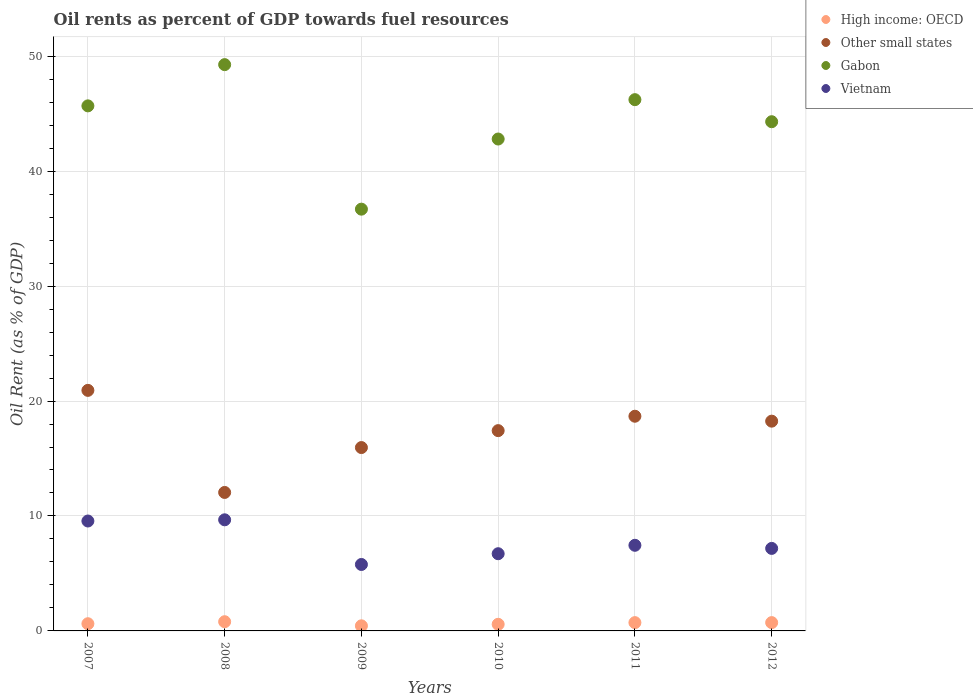What is the oil rent in Vietnam in 2008?
Offer a very short reply. 9.67. Across all years, what is the maximum oil rent in Other small states?
Keep it short and to the point. 20.93. Across all years, what is the minimum oil rent in High income: OECD?
Your answer should be very brief. 0.44. In which year was the oil rent in Vietnam maximum?
Provide a succinct answer. 2008. What is the total oil rent in Vietnam in the graph?
Your answer should be compact. 46.35. What is the difference between the oil rent in Vietnam in 2007 and that in 2010?
Provide a short and direct response. 2.85. What is the difference between the oil rent in Gabon in 2012 and the oil rent in Vietnam in 2008?
Offer a very short reply. 34.63. What is the average oil rent in High income: OECD per year?
Offer a terse response. 0.65. In the year 2011, what is the difference between the oil rent in Vietnam and oil rent in Gabon?
Your response must be concise. -38.77. What is the ratio of the oil rent in High income: OECD in 2008 to that in 2012?
Ensure brevity in your answer.  1.11. What is the difference between the highest and the second highest oil rent in Other small states?
Provide a short and direct response. 2.25. What is the difference between the highest and the lowest oil rent in High income: OECD?
Keep it short and to the point. 0.36. Is the sum of the oil rent in Other small states in 2010 and 2011 greater than the maximum oil rent in High income: OECD across all years?
Make the answer very short. Yes. Is it the case that in every year, the sum of the oil rent in Gabon and oil rent in Vietnam  is greater than the sum of oil rent in Other small states and oil rent in High income: OECD?
Keep it short and to the point. No. Is the oil rent in Gabon strictly greater than the oil rent in High income: OECD over the years?
Provide a succinct answer. Yes. Is the oil rent in High income: OECD strictly less than the oil rent in Gabon over the years?
Make the answer very short. Yes. How many dotlines are there?
Ensure brevity in your answer.  4. What is the difference between two consecutive major ticks on the Y-axis?
Provide a short and direct response. 10. Are the values on the major ticks of Y-axis written in scientific E-notation?
Your response must be concise. No. Does the graph contain any zero values?
Ensure brevity in your answer.  No. Does the graph contain grids?
Your answer should be very brief. Yes. Where does the legend appear in the graph?
Provide a short and direct response. Top right. How many legend labels are there?
Offer a very short reply. 4. What is the title of the graph?
Offer a terse response. Oil rents as percent of GDP towards fuel resources. Does "China" appear as one of the legend labels in the graph?
Your answer should be compact. No. What is the label or title of the Y-axis?
Make the answer very short. Oil Rent (as % of GDP). What is the Oil Rent (as % of GDP) in High income: OECD in 2007?
Your answer should be compact. 0.63. What is the Oil Rent (as % of GDP) of Other small states in 2007?
Give a very brief answer. 20.93. What is the Oil Rent (as % of GDP) of Gabon in 2007?
Your answer should be compact. 45.68. What is the Oil Rent (as % of GDP) in Vietnam in 2007?
Ensure brevity in your answer.  9.56. What is the Oil Rent (as % of GDP) of High income: OECD in 2008?
Your response must be concise. 0.8. What is the Oil Rent (as % of GDP) of Other small states in 2008?
Your response must be concise. 12.05. What is the Oil Rent (as % of GDP) of Gabon in 2008?
Ensure brevity in your answer.  49.26. What is the Oil Rent (as % of GDP) in Vietnam in 2008?
Make the answer very short. 9.67. What is the Oil Rent (as % of GDP) in High income: OECD in 2009?
Make the answer very short. 0.44. What is the Oil Rent (as % of GDP) of Other small states in 2009?
Offer a terse response. 15.95. What is the Oil Rent (as % of GDP) of Gabon in 2009?
Give a very brief answer. 36.69. What is the Oil Rent (as % of GDP) of Vietnam in 2009?
Your answer should be very brief. 5.78. What is the Oil Rent (as % of GDP) in High income: OECD in 2010?
Offer a very short reply. 0.58. What is the Oil Rent (as % of GDP) of Other small states in 2010?
Your answer should be compact. 17.42. What is the Oil Rent (as % of GDP) of Gabon in 2010?
Provide a succinct answer. 42.79. What is the Oil Rent (as % of GDP) in Vietnam in 2010?
Your answer should be compact. 6.72. What is the Oil Rent (as % of GDP) of High income: OECD in 2011?
Keep it short and to the point. 0.72. What is the Oil Rent (as % of GDP) in Other small states in 2011?
Give a very brief answer. 18.68. What is the Oil Rent (as % of GDP) of Gabon in 2011?
Provide a succinct answer. 46.22. What is the Oil Rent (as % of GDP) of Vietnam in 2011?
Provide a short and direct response. 7.45. What is the Oil Rent (as % of GDP) in High income: OECD in 2012?
Provide a short and direct response. 0.72. What is the Oil Rent (as % of GDP) in Other small states in 2012?
Provide a short and direct response. 18.25. What is the Oil Rent (as % of GDP) of Gabon in 2012?
Keep it short and to the point. 44.3. What is the Oil Rent (as % of GDP) in Vietnam in 2012?
Keep it short and to the point. 7.18. Across all years, what is the maximum Oil Rent (as % of GDP) of High income: OECD?
Your answer should be compact. 0.8. Across all years, what is the maximum Oil Rent (as % of GDP) in Other small states?
Make the answer very short. 20.93. Across all years, what is the maximum Oil Rent (as % of GDP) in Gabon?
Give a very brief answer. 49.26. Across all years, what is the maximum Oil Rent (as % of GDP) in Vietnam?
Your answer should be very brief. 9.67. Across all years, what is the minimum Oil Rent (as % of GDP) of High income: OECD?
Your response must be concise. 0.44. Across all years, what is the minimum Oil Rent (as % of GDP) of Other small states?
Provide a short and direct response. 12.05. Across all years, what is the minimum Oil Rent (as % of GDP) of Gabon?
Offer a terse response. 36.69. Across all years, what is the minimum Oil Rent (as % of GDP) of Vietnam?
Provide a succinct answer. 5.78. What is the total Oil Rent (as % of GDP) of High income: OECD in the graph?
Offer a terse response. 3.89. What is the total Oil Rent (as % of GDP) in Other small states in the graph?
Give a very brief answer. 103.27. What is the total Oil Rent (as % of GDP) in Gabon in the graph?
Your response must be concise. 264.94. What is the total Oil Rent (as % of GDP) of Vietnam in the graph?
Make the answer very short. 46.35. What is the difference between the Oil Rent (as % of GDP) of High income: OECD in 2007 and that in 2008?
Offer a terse response. -0.17. What is the difference between the Oil Rent (as % of GDP) in Other small states in 2007 and that in 2008?
Offer a very short reply. 8.88. What is the difference between the Oil Rent (as % of GDP) in Gabon in 2007 and that in 2008?
Ensure brevity in your answer.  -3.59. What is the difference between the Oil Rent (as % of GDP) of Vietnam in 2007 and that in 2008?
Offer a very short reply. -0.1. What is the difference between the Oil Rent (as % of GDP) of High income: OECD in 2007 and that in 2009?
Ensure brevity in your answer.  0.18. What is the difference between the Oil Rent (as % of GDP) in Other small states in 2007 and that in 2009?
Make the answer very short. 4.98. What is the difference between the Oil Rent (as % of GDP) of Gabon in 2007 and that in 2009?
Offer a terse response. 8.99. What is the difference between the Oil Rent (as % of GDP) in Vietnam in 2007 and that in 2009?
Ensure brevity in your answer.  3.78. What is the difference between the Oil Rent (as % of GDP) in High income: OECD in 2007 and that in 2010?
Ensure brevity in your answer.  0.05. What is the difference between the Oil Rent (as % of GDP) of Other small states in 2007 and that in 2010?
Your answer should be very brief. 3.5. What is the difference between the Oil Rent (as % of GDP) in Gabon in 2007 and that in 2010?
Keep it short and to the point. 2.88. What is the difference between the Oil Rent (as % of GDP) in Vietnam in 2007 and that in 2010?
Make the answer very short. 2.85. What is the difference between the Oil Rent (as % of GDP) of High income: OECD in 2007 and that in 2011?
Your response must be concise. -0.1. What is the difference between the Oil Rent (as % of GDP) in Other small states in 2007 and that in 2011?
Ensure brevity in your answer.  2.25. What is the difference between the Oil Rent (as % of GDP) in Gabon in 2007 and that in 2011?
Offer a very short reply. -0.54. What is the difference between the Oil Rent (as % of GDP) of Vietnam in 2007 and that in 2011?
Your response must be concise. 2.11. What is the difference between the Oil Rent (as % of GDP) in High income: OECD in 2007 and that in 2012?
Your answer should be very brief. -0.1. What is the difference between the Oil Rent (as % of GDP) of Other small states in 2007 and that in 2012?
Keep it short and to the point. 2.68. What is the difference between the Oil Rent (as % of GDP) in Gabon in 2007 and that in 2012?
Provide a succinct answer. 1.38. What is the difference between the Oil Rent (as % of GDP) of Vietnam in 2007 and that in 2012?
Keep it short and to the point. 2.38. What is the difference between the Oil Rent (as % of GDP) of High income: OECD in 2008 and that in 2009?
Provide a short and direct response. 0.36. What is the difference between the Oil Rent (as % of GDP) of Other small states in 2008 and that in 2009?
Provide a succinct answer. -3.9. What is the difference between the Oil Rent (as % of GDP) in Gabon in 2008 and that in 2009?
Make the answer very short. 12.57. What is the difference between the Oil Rent (as % of GDP) of Vietnam in 2008 and that in 2009?
Provide a succinct answer. 3.89. What is the difference between the Oil Rent (as % of GDP) in High income: OECD in 2008 and that in 2010?
Your answer should be compact. 0.23. What is the difference between the Oil Rent (as % of GDP) of Other small states in 2008 and that in 2010?
Your answer should be compact. -5.38. What is the difference between the Oil Rent (as % of GDP) of Gabon in 2008 and that in 2010?
Offer a terse response. 6.47. What is the difference between the Oil Rent (as % of GDP) in Vietnam in 2008 and that in 2010?
Your answer should be compact. 2.95. What is the difference between the Oil Rent (as % of GDP) in High income: OECD in 2008 and that in 2011?
Keep it short and to the point. 0.08. What is the difference between the Oil Rent (as % of GDP) in Other small states in 2008 and that in 2011?
Keep it short and to the point. -6.63. What is the difference between the Oil Rent (as % of GDP) of Gabon in 2008 and that in 2011?
Your response must be concise. 3.05. What is the difference between the Oil Rent (as % of GDP) in Vietnam in 2008 and that in 2011?
Your answer should be very brief. 2.22. What is the difference between the Oil Rent (as % of GDP) of High income: OECD in 2008 and that in 2012?
Ensure brevity in your answer.  0.08. What is the difference between the Oil Rent (as % of GDP) in Other small states in 2008 and that in 2012?
Keep it short and to the point. -6.2. What is the difference between the Oil Rent (as % of GDP) of Gabon in 2008 and that in 2012?
Keep it short and to the point. 4.97. What is the difference between the Oil Rent (as % of GDP) of Vietnam in 2008 and that in 2012?
Make the answer very short. 2.49. What is the difference between the Oil Rent (as % of GDP) in High income: OECD in 2009 and that in 2010?
Make the answer very short. -0.13. What is the difference between the Oil Rent (as % of GDP) of Other small states in 2009 and that in 2010?
Provide a succinct answer. -1.47. What is the difference between the Oil Rent (as % of GDP) of Gabon in 2009 and that in 2010?
Offer a terse response. -6.1. What is the difference between the Oil Rent (as % of GDP) in Vietnam in 2009 and that in 2010?
Keep it short and to the point. -0.94. What is the difference between the Oil Rent (as % of GDP) in High income: OECD in 2009 and that in 2011?
Offer a very short reply. -0.28. What is the difference between the Oil Rent (as % of GDP) of Other small states in 2009 and that in 2011?
Provide a succinct answer. -2.73. What is the difference between the Oil Rent (as % of GDP) of Gabon in 2009 and that in 2011?
Make the answer very short. -9.53. What is the difference between the Oil Rent (as % of GDP) in Vietnam in 2009 and that in 2011?
Offer a very short reply. -1.67. What is the difference between the Oil Rent (as % of GDP) in High income: OECD in 2009 and that in 2012?
Make the answer very short. -0.28. What is the difference between the Oil Rent (as % of GDP) of Other small states in 2009 and that in 2012?
Ensure brevity in your answer.  -2.3. What is the difference between the Oil Rent (as % of GDP) in Gabon in 2009 and that in 2012?
Ensure brevity in your answer.  -7.61. What is the difference between the Oil Rent (as % of GDP) of Vietnam in 2009 and that in 2012?
Ensure brevity in your answer.  -1.4. What is the difference between the Oil Rent (as % of GDP) in High income: OECD in 2010 and that in 2011?
Provide a short and direct response. -0.15. What is the difference between the Oil Rent (as % of GDP) in Other small states in 2010 and that in 2011?
Give a very brief answer. -1.25. What is the difference between the Oil Rent (as % of GDP) of Gabon in 2010 and that in 2011?
Ensure brevity in your answer.  -3.42. What is the difference between the Oil Rent (as % of GDP) in Vietnam in 2010 and that in 2011?
Offer a very short reply. -0.73. What is the difference between the Oil Rent (as % of GDP) of High income: OECD in 2010 and that in 2012?
Your answer should be compact. -0.15. What is the difference between the Oil Rent (as % of GDP) in Other small states in 2010 and that in 2012?
Offer a very short reply. -0.82. What is the difference between the Oil Rent (as % of GDP) of Gabon in 2010 and that in 2012?
Provide a succinct answer. -1.51. What is the difference between the Oil Rent (as % of GDP) in Vietnam in 2010 and that in 2012?
Offer a terse response. -0.46. What is the difference between the Oil Rent (as % of GDP) of High income: OECD in 2011 and that in 2012?
Your answer should be very brief. -0. What is the difference between the Oil Rent (as % of GDP) in Other small states in 2011 and that in 2012?
Offer a very short reply. 0.43. What is the difference between the Oil Rent (as % of GDP) in Gabon in 2011 and that in 2012?
Offer a very short reply. 1.92. What is the difference between the Oil Rent (as % of GDP) of Vietnam in 2011 and that in 2012?
Make the answer very short. 0.27. What is the difference between the Oil Rent (as % of GDP) of High income: OECD in 2007 and the Oil Rent (as % of GDP) of Other small states in 2008?
Offer a very short reply. -11.42. What is the difference between the Oil Rent (as % of GDP) of High income: OECD in 2007 and the Oil Rent (as % of GDP) of Gabon in 2008?
Provide a succinct answer. -48.64. What is the difference between the Oil Rent (as % of GDP) of High income: OECD in 2007 and the Oil Rent (as % of GDP) of Vietnam in 2008?
Keep it short and to the point. -9.04. What is the difference between the Oil Rent (as % of GDP) of Other small states in 2007 and the Oil Rent (as % of GDP) of Gabon in 2008?
Ensure brevity in your answer.  -28.34. What is the difference between the Oil Rent (as % of GDP) in Other small states in 2007 and the Oil Rent (as % of GDP) in Vietnam in 2008?
Provide a short and direct response. 11.26. What is the difference between the Oil Rent (as % of GDP) in Gabon in 2007 and the Oil Rent (as % of GDP) in Vietnam in 2008?
Your answer should be very brief. 36.01. What is the difference between the Oil Rent (as % of GDP) of High income: OECD in 2007 and the Oil Rent (as % of GDP) of Other small states in 2009?
Provide a succinct answer. -15.32. What is the difference between the Oil Rent (as % of GDP) in High income: OECD in 2007 and the Oil Rent (as % of GDP) in Gabon in 2009?
Ensure brevity in your answer.  -36.07. What is the difference between the Oil Rent (as % of GDP) of High income: OECD in 2007 and the Oil Rent (as % of GDP) of Vietnam in 2009?
Offer a very short reply. -5.15. What is the difference between the Oil Rent (as % of GDP) in Other small states in 2007 and the Oil Rent (as % of GDP) in Gabon in 2009?
Your answer should be very brief. -15.76. What is the difference between the Oil Rent (as % of GDP) in Other small states in 2007 and the Oil Rent (as % of GDP) in Vietnam in 2009?
Ensure brevity in your answer.  15.15. What is the difference between the Oil Rent (as % of GDP) of Gabon in 2007 and the Oil Rent (as % of GDP) of Vietnam in 2009?
Keep it short and to the point. 39.9. What is the difference between the Oil Rent (as % of GDP) of High income: OECD in 2007 and the Oil Rent (as % of GDP) of Other small states in 2010?
Your answer should be compact. -16.8. What is the difference between the Oil Rent (as % of GDP) in High income: OECD in 2007 and the Oil Rent (as % of GDP) in Gabon in 2010?
Offer a very short reply. -42.17. What is the difference between the Oil Rent (as % of GDP) of High income: OECD in 2007 and the Oil Rent (as % of GDP) of Vietnam in 2010?
Make the answer very short. -6.09. What is the difference between the Oil Rent (as % of GDP) of Other small states in 2007 and the Oil Rent (as % of GDP) of Gabon in 2010?
Your response must be concise. -21.87. What is the difference between the Oil Rent (as % of GDP) in Other small states in 2007 and the Oil Rent (as % of GDP) in Vietnam in 2010?
Provide a short and direct response. 14.21. What is the difference between the Oil Rent (as % of GDP) in Gabon in 2007 and the Oil Rent (as % of GDP) in Vietnam in 2010?
Keep it short and to the point. 38.96. What is the difference between the Oil Rent (as % of GDP) of High income: OECD in 2007 and the Oil Rent (as % of GDP) of Other small states in 2011?
Give a very brief answer. -18.05. What is the difference between the Oil Rent (as % of GDP) in High income: OECD in 2007 and the Oil Rent (as % of GDP) in Gabon in 2011?
Offer a terse response. -45.59. What is the difference between the Oil Rent (as % of GDP) in High income: OECD in 2007 and the Oil Rent (as % of GDP) in Vietnam in 2011?
Your answer should be compact. -6.82. What is the difference between the Oil Rent (as % of GDP) in Other small states in 2007 and the Oil Rent (as % of GDP) in Gabon in 2011?
Your answer should be compact. -25.29. What is the difference between the Oil Rent (as % of GDP) in Other small states in 2007 and the Oil Rent (as % of GDP) in Vietnam in 2011?
Your response must be concise. 13.48. What is the difference between the Oil Rent (as % of GDP) of Gabon in 2007 and the Oil Rent (as % of GDP) of Vietnam in 2011?
Offer a very short reply. 38.23. What is the difference between the Oil Rent (as % of GDP) of High income: OECD in 2007 and the Oil Rent (as % of GDP) of Other small states in 2012?
Give a very brief answer. -17.62. What is the difference between the Oil Rent (as % of GDP) in High income: OECD in 2007 and the Oil Rent (as % of GDP) in Gabon in 2012?
Your answer should be compact. -43.67. What is the difference between the Oil Rent (as % of GDP) of High income: OECD in 2007 and the Oil Rent (as % of GDP) of Vietnam in 2012?
Provide a short and direct response. -6.55. What is the difference between the Oil Rent (as % of GDP) in Other small states in 2007 and the Oil Rent (as % of GDP) in Gabon in 2012?
Your answer should be compact. -23.37. What is the difference between the Oil Rent (as % of GDP) of Other small states in 2007 and the Oil Rent (as % of GDP) of Vietnam in 2012?
Offer a very short reply. 13.75. What is the difference between the Oil Rent (as % of GDP) in Gabon in 2007 and the Oil Rent (as % of GDP) in Vietnam in 2012?
Offer a terse response. 38.5. What is the difference between the Oil Rent (as % of GDP) of High income: OECD in 2008 and the Oil Rent (as % of GDP) of Other small states in 2009?
Give a very brief answer. -15.15. What is the difference between the Oil Rent (as % of GDP) in High income: OECD in 2008 and the Oil Rent (as % of GDP) in Gabon in 2009?
Offer a very short reply. -35.89. What is the difference between the Oil Rent (as % of GDP) of High income: OECD in 2008 and the Oil Rent (as % of GDP) of Vietnam in 2009?
Your answer should be compact. -4.98. What is the difference between the Oil Rent (as % of GDP) of Other small states in 2008 and the Oil Rent (as % of GDP) of Gabon in 2009?
Offer a very short reply. -24.64. What is the difference between the Oil Rent (as % of GDP) of Other small states in 2008 and the Oil Rent (as % of GDP) of Vietnam in 2009?
Make the answer very short. 6.27. What is the difference between the Oil Rent (as % of GDP) of Gabon in 2008 and the Oil Rent (as % of GDP) of Vietnam in 2009?
Your answer should be compact. 43.48. What is the difference between the Oil Rent (as % of GDP) of High income: OECD in 2008 and the Oil Rent (as % of GDP) of Other small states in 2010?
Provide a short and direct response. -16.62. What is the difference between the Oil Rent (as % of GDP) in High income: OECD in 2008 and the Oil Rent (as % of GDP) in Gabon in 2010?
Make the answer very short. -41.99. What is the difference between the Oil Rent (as % of GDP) in High income: OECD in 2008 and the Oil Rent (as % of GDP) in Vietnam in 2010?
Your answer should be very brief. -5.92. What is the difference between the Oil Rent (as % of GDP) in Other small states in 2008 and the Oil Rent (as % of GDP) in Gabon in 2010?
Offer a very short reply. -30.75. What is the difference between the Oil Rent (as % of GDP) of Other small states in 2008 and the Oil Rent (as % of GDP) of Vietnam in 2010?
Your answer should be very brief. 5.33. What is the difference between the Oil Rent (as % of GDP) of Gabon in 2008 and the Oil Rent (as % of GDP) of Vietnam in 2010?
Make the answer very short. 42.55. What is the difference between the Oil Rent (as % of GDP) of High income: OECD in 2008 and the Oil Rent (as % of GDP) of Other small states in 2011?
Offer a very short reply. -17.88. What is the difference between the Oil Rent (as % of GDP) of High income: OECD in 2008 and the Oil Rent (as % of GDP) of Gabon in 2011?
Your response must be concise. -45.42. What is the difference between the Oil Rent (as % of GDP) in High income: OECD in 2008 and the Oil Rent (as % of GDP) in Vietnam in 2011?
Offer a terse response. -6.65. What is the difference between the Oil Rent (as % of GDP) in Other small states in 2008 and the Oil Rent (as % of GDP) in Gabon in 2011?
Offer a terse response. -34.17. What is the difference between the Oil Rent (as % of GDP) of Other small states in 2008 and the Oil Rent (as % of GDP) of Vietnam in 2011?
Keep it short and to the point. 4.6. What is the difference between the Oil Rent (as % of GDP) in Gabon in 2008 and the Oil Rent (as % of GDP) in Vietnam in 2011?
Your response must be concise. 41.82. What is the difference between the Oil Rent (as % of GDP) of High income: OECD in 2008 and the Oil Rent (as % of GDP) of Other small states in 2012?
Make the answer very short. -17.45. What is the difference between the Oil Rent (as % of GDP) in High income: OECD in 2008 and the Oil Rent (as % of GDP) in Gabon in 2012?
Offer a terse response. -43.5. What is the difference between the Oil Rent (as % of GDP) in High income: OECD in 2008 and the Oil Rent (as % of GDP) in Vietnam in 2012?
Give a very brief answer. -6.38. What is the difference between the Oil Rent (as % of GDP) of Other small states in 2008 and the Oil Rent (as % of GDP) of Gabon in 2012?
Ensure brevity in your answer.  -32.25. What is the difference between the Oil Rent (as % of GDP) of Other small states in 2008 and the Oil Rent (as % of GDP) of Vietnam in 2012?
Provide a succinct answer. 4.87. What is the difference between the Oil Rent (as % of GDP) of Gabon in 2008 and the Oil Rent (as % of GDP) of Vietnam in 2012?
Offer a terse response. 42.09. What is the difference between the Oil Rent (as % of GDP) in High income: OECD in 2009 and the Oil Rent (as % of GDP) in Other small states in 2010?
Ensure brevity in your answer.  -16.98. What is the difference between the Oil Rent (as % of GDP) in High income: OECD in 2009 and the Oil Rent (as % of GDP) in Gabon in 2010?
Offer a terse response. -42.35. What is the difference between the Oil Rent (as % of GDP) in High income: OECD in 2009 and the Oil Rent (as % of GDP) in Vietnam in 2010?
Give a very brief answer. -6.27. What is the difference between the Oil Rent (as % of GDP) of Other small states in 2009 and the Oil Rent (as % of GDP) of Gabon in 2010?
Keep it short and to the point. -26.84. What is the difference between the Oil Rent (as % of GDP) in Other small states in 2009 and the Oil Rent (as % of GDP) in Vietnam in 2010?
Provide a succinct answer. 9.23. What is the difference between the Oil Rent (as % of GDP) in Gabon in 2009 and the Oil Rent (as % of GDP) in Vietnam in 2010?
Give a very brief answer. 29.98. What is the difference between the Oil Rent (as % of GDP) in High income: OECD in 2009 and the Oil Rent (as % of GDP) in Other small states in 2011?
Offer a very short reply. -18.23. What is the difference between the Oil Rent (as % of GDP) of High income: OECD in 2009 and the Oil Rent (as % of GDP) of Gabon in 2011?
Your response must be concise. -45.77. What is the difference between the Oil Rent (as % of GDP) in High income: OECD in 2009 and the Oil Rent (as % of GDP) in Vietnam in 2011?
Provide a short and direct response. -7. What is the difference between the Oil Rent (as % of GDP) of Other small states in 2009 and the Oil Rent (as % of GDP) of Gabon in 2011?
Offer a very short reply. -30.27. What is the difference between the Oil Rent (as % of GDP) of Other small states in 2009 and the Oil Rent (as % of GDP) of Vietnam in 2011?
Make the answer very short. 8.5. What is the difference between the Oil Rent (as % of GDP) of Gabon in 2009 and the Oil Rent (as % of GDP) of Vietnam in 2011?
Your response must be concise. 29.24. What is the difference between the Oil Rent (as % of GDP) of High income: OECD in 2009 and the Oil Rent (as % of GDP) of Other small states in 2012?
Offer a very short reply. -17.8. What is the difference between the Oil Rent (as % of GDP) in High income: OECD in 2009 and the Oil Rent (as % of GDP) in Gabon in 2012?
Give a very brief answer. -43.85. What is the difference between the Oil Rent (as % of GDP) of High income: OECD in 2009 and the Oil Rent (as % of GDP) of Vietnam in 2012?
Provide a short and direct response. -6.73. What is the difference between the Oil Rent (as % of GDP) of Other small states in 2009 and the Oil Rent (as % of GDP) of Gabon in 2012?
Give a very brief answer. -28.35. What is the difference between the Oil Rent (as % of GDP) in Other small states in 2009 and the Oil Rent (as % of GDP) in Vietnam in 2012?
Provide a succinct answer. 8.77. What is the difference between the Oil Rent (as % of GDP) in Gabon in 2009 and the Oil Rent (as % of GDP) in Vietnam in 2012?
Your answer should be compact. 29.51. What is the difference between the Oil Rent (as % of GDP) in High income: OECD in 2010 and the Oil Rent (as % of GDP) in Other small states in 2011?
Keep it short and to the point. -18.1. What is the difference between the Oil Rent (as % of GDP) in High income: OECD in 2010 and the Oil Rent (as % of GDP) in Gabon in 2011?
Your answer should be very brief. -45.64. What is the difference between the Oil Rent (as % of GDP) in High income: OECD in 2010 and the Oil Rent (as % of GDP) in Vietnam in 2011?
Provide a succinct answer. -6.87. What is the difference between the Oil Rent (as % of GDP) in Other small states in 2010 and the Oil Rent (as % of GDP) in Gabon in 2011?
Offer a very short reply. -28.79. What is the difference between the Oil Rent (as % of GDP) of Other small states in 2010 and the Oil Rent (as % of GDP) of Vietnam in 2011?
Offer a terse response. 9.98. What is the difference between the Oil Rent (as % of GDP) in Gabon in 2010 and the Oil Rent (as % of GDP) in Vietnam in 2011?
Provide a short and direct response. 35.34. What is the difference between the Oil Rent (as % of GDP) in High income: OECD in 2010 and the Oil Rent (as % of GDP) in Other small states in 2012?
Make the answer very short. -17.67. What is the difference between the Oil Rent (as % of GDP) of High income: OECD in 2010 and the Oil Rent (as % of GDP) of Gabon in 2012?
Give a very brief answer. -43.72. What is the difference between the Oil Rent (as % of GDP) of High income: OECD in 2010 and the Oil Rent (as % of GDP) of Vietnam in 2012?
Your answer should be compact. -6.6. What is the difference between the Oil Rent (as % of GDP) of Other small states in 2010 and the Oil Rent (as % of GDP) of Gabon in 2012?
Keep it short and to the point. -26.87. What is the difference between the Oil Rent (as % of GDP) in Other small states in 2010 and the Oil Rent (as % of GDP) in Vietnam in 2012?
Give a very brief answer. 10.25. What is the difference between the Oil Rent (as % of GDP) of Gabon in 2010 and the Oil Rent (as % of GDP) of Vietnam in 2012?
Keep it short and to the point. 35.61. What is the difference between the Oil Rent (as % of GDP) of High income: OECD in 2011 and the Oil Rent (as % of GDP) of Other small states in 2012?
Your answer should be very brief. -17.53. What is the difference between the Oil Rent (as % of GDP) in High income: OECD in 2011 and the Oil Rent (as % of GDP) in Gabon in 2012?
Provide a short and direct response. -43.58. What is the difference between the Oil Rent (as % of GDP) of High income: OECD in 2011 and the Oil Rent (as % of GDP) of Vietnam in 2012?
Provide a succinct answer. -6.46. What is the difference between the Oil Rent (as % of GDP) in Other small states in 2011 and the Oil Rent (as % of GDP) in Gabon in 2012?
Keep it short and to the point. -25.62. What is the difference between the Oil Rent (as % of GDP) in Other small states in 2011 and the Oil Rent (as % of GDP) in Vietnam in 2012?
Give a very brief answer. 11.5. What is the difference between the Oil Rent (as % of GDP) of Gabon in 2011 and the Oil Rent (as % of GDP) of Vietnam in 2012?
Your response must be concise. 39.04. What is the average Oil Rent (as % of GDP) in High income: OECD per year?
Offer a terse response. 0.65. What is the average Oil Rent (as % of GDP) in Other small states per year?
Offer a very short reply. 17.21. What is the average Oil Rent (as % of GDP) in Gabon per year?
Give a very brief answer. 44.16. What is the average Oil Rent (as % of GDP) of Vietnam per year?
Your answer should be compact. 7.73. In the year 2007, what is the difference between the Oil Rent (as % of GDP) in High income: OECD and Oil Rent (as % of GDP) in Other small states?
Offer a very short reply. -20.3. In the year 2007, what is the difference between the Oil Rent (as % of GDP) in High income: OECD and Oil Rent (as % of GDP) in Gabon?
Offer a terse response. -45.05. In the year 2007, what is the difference between the Oil Rent (as % of GDP) of High income: OECD and Oil Rent (as % of GDP) of Vietnam?
Give a very brief answer. -8.94. In the year 2007, what is the difference between the Oil Rent (as % of GDP) of Other small states and Oil Rent (as % of GDP) of Gabon?
Your response must be concise. -24.75. In the year 2007, what is the difference between the Oil Rent (as % of GDP) of Other small states and Oil Rent (as % of GDP) of Vietnam?
Your response must be concise. 11.37. In the year 2007, what is the difference between the Oil Rent (as % of GDP) of Gabon and Oil Rent (as % of GDP) of Vietnam?
Your answer should be compact. 36.12. In the year 2008, what is the difference between the Oil Rent (as % of GDP) of High income: OECD and Oil Rent (as % of GDP) of Other small states?
Your response must be concise. -11.25. In the year 2008, what is the difference between the Oil Rent (as % of GDP) of High income: OECD and Oil Rent (as % of GDP) of Gabon?
Your response must be concise. -48.46. In the year 2008, what is the difference between the Oil Rent (as % of GDP) of High income: OECD and Oil Rent (as % of GDP) of Vietnam?
Ensure brevity in your answer.  -8.87. In the year 2008, what is the difference between the Oil Rent (as % of GDP) in Other small states and Oil Rent (as % of GDP) in Gabon?
Provide a succinct answer. -37.22. In the year 2008, what is the difference between the Oil Rent (as % of GDP) in Other small states and Oil Rent (as % of GDP) in Vietnam?
Offer a terse response. 2.38. In the year 2008, what is the difference between the Oil Rent (as % of GDP) of Gabon and Oil Rent (as % of GDP) of Vietnam?
Offer a very short reply. 39.6. In the year 2009, what is the difference between the Oil Rent (as % of GDP) of High income: OECD and Oil Rent (as % of GDP) of Other small states?
Provide a short and direct response. -15.51. In the year 2009, what is the difference between the Oil Rent (as % of GDP) of High income: OECD and Oil Rent (as % of GDP) of Gabon?
Ensure brevity in your answer.  -36.25. In the year 2009, what is the difference between the Oil Rent (as % of GDP) of High income: OECD and Oil Rent (as % of GDP) of Vietnam?
Provide a succinct answer. -5.34. In the year 2009, what is the difference between the Oil Rent (as % of GDP) of Other small states and Oil Rent (as % of GDP) of Gabon?
Offer a terse response. -20.74. In the year 2009, what is the difference between the Oil Rent (as % of GDP) of Other small states and Oil Rent (as % of GDP) of Vietnam?
Ensure brevity in your answer.  10.17. In the year 2009, what is the difference between the Oil Rent (as % of GDP) of Gabon and Oil Rent (as % of GDP) of Vietnam?
Provide a succinct answer. 30.91. In the year 2010, what is the difference between the Oil Rent (as % of GDP) in High income: OECD and Oil Rent (as % of GDP) in Other small states?
Provide a succinct answer. -16.85. In the year 2010, what is the difference between the Oil Rent (as % of GDP) of High income: OECD and Oil Rent (as % of GDP) of Gabon?
Your response must be concise. -42.22. In the year 2010, what is the difference between the Oil Rent (as % of GDP) in High income: OECD and Oil Rent (as % of GDP) in Vietnam?
Give a very brief answer. -6.14. In the year 2010, what is the difference between the Oil Rent (as % of GDP) of Other small states and Oil Rent (as % of GDP) of Gabon?
Offer a terse response. -25.37. In the year 2010, what is the difference between the Oil Rent (as % of GDP) in Other small states and Oil Rent (as % of GDP) in Vietnam?
Your answer should be compact. 10.71. In the year 2010, what is the difference between the Oil Rent (as % of GDP) in Gabon and Oil Rent (as % of GDP) in Vietnam?
Offer a very short reply. 36.08. In the year 2011, what is the difference between the Oil Rent (as % of GDP) in High income: OECD and Oil Rent (as % of GDP) in Other small states?
Your response must be concise. -17.95. In the year 2011, what is the difference between the Oil Rent (as % of GDP) in High income: OECD and Oil Rent (as % of GDP) in Gabon?
Provide a short and direct response. -45.5. In the year 2011, what is the difference between the Oil Rent (as % of GDP) of High income: OECD and Oil Rent (as % of GDP) of Vietnam?
Give a very brief answer. -6.73. In the year 2011, what is the difference between the Oil Rent (as % of GDP) of Other small states and Oil Rent (as % of GDP) of Gabon?
Offer a terse response. -27.54. In the year 2011, what is the difference between the Oil Rent (as % of GDP) of Other small states and Oil Rent (as % of GDP) of Vietnam?
Give a very brief answer. 11.23. In the year 2011, what is the difference between the Oil Rent (as % of GDP) of Gabon and Oil Rent (as % of GDP) of Vietnam?
Give a very brief answer. 38.77. In the year 2012, what is the difference between the Oil Rent (as % of GDP) in High income: OECD and Oil Rent (as % of GDP) in Other small states?
Offer a very short reply. -17.53. In the year 2012, what is the difference between the Oil Rent (as % of GDP) of High income: OECD and Oil Rent (as % of GDP) of Gabon?
Provide a short and direct response. -43.58. In the year 2012, what is the difference between the Oil Rent (as % of GDP) in High income: OECD and Oil Rent (as % of GDP) in Vietnam?
Your answer should be compact. -6.46. In the year 2012, what is the difference between the Oil Rent (as % of GDP) of Other small states and Oil Rent (as % of GDP) of Gabon?
Your answer should be very brief. -26.05. In the year 2012, what is the difference between the Oil Rent (as % of GDP) of Other small states and Oil Rent (as % of GDP) of Vietnam?
Your answer should be very brief. 11.07. In the year 2012, what is the difference between the Oil Rent (as % of GDP) in Gabon and Oil Rent (as % of GDP) in Vietnam?
Offer a terse response. 37.12. What is the ratio of the Oil Rent (as % of GDP) of High income: OECD in 2007 to that in 2008?
Offer a very short reply. 0.78. What is the ratio of the Oil Rent (as % of GDP) of Other small states in 2007 to that in 2008?
Your answer should be very brief. 1.74. What is the ratio of the Oil Rent (as % of GDP) of Gabon in 2007 to that in 2008?
Your answer should be very brief. 0.93. What is the ratio of the Oil Rent (as % of GDP) in High income: OECD in 2007 to that in 2009?
Offer a terse response. 1.41. What is the ratio of the Oil Rent (as % of GDP) of Other small states in 2007 to that in 2009?
Provide a succinct answer. 1.31. What is the ratio of the Oil Rent (as % of GDP) of Gabon in 2007 to that in 2009?
Provide a short and direct response. 1.24. What is the ratio of the Oil Rent (as % of GDP) in Vietnam in 2007 to that in 2009?
Your answer should be compact. 1.65. What is the ratio of the Oil Rent (as % of GDP) of High income: OECD in 2007 to that in 2010?
Ensure brevity in your answer.  1.09. What is the ratio of the Oil Rent (as % of GDP) in Other small states in 2007 to that in 2010?
Ensure brevity in your answer.  1.2. What is the ratio of the Oil Rent (as % of GDP) in Gabon in 2007 to that in 2010?
Your response must be concise. 1.07. What is the ratio of the Oil Rent (as % of GDP) in Vietnam in 2007 to that in 2010?
Keep it short and to the point. 1.42. What is the ratio of the Oil Rent (as % of GDP) of High income: OECD in 2007 to that in 2011?
Offer a very short reply. 0.87. What is the ratio of the Oil Rent (as % of GDP) in Other small states in 2007 to that in 2011?
Your answer should be compact. 1.12. What is the ratio of the Oil Rent (as % of GDP) in Gabon in 2007 to that in 2011?
Your answer should be compact. 0.99. What is the ratio of the Oil Rent (as % of GDP) of Vietnam in 2007 to that in 2011?
Provide a short and direct response. 1.28. What is the ratio of the Oil Rent (as % of GDP) in High income: OECD in 2007 to that in 2012?
Offer a terse response. 0.87. What is the ratio of the Oil Rent (as % of GDP) of Other small states in 2007 to that in 2012?
Provide a succinct answer. 1.15. What is the ratio of the Oil Rent (as % of GDP) in Gabon in 2007 to that in 2012?
Your answer should be compact. 1.03. What is the ratio of the Oil Rent (as % of GDP) of Vietnam in 2007 to that in 2012?
Give a very brief answer. 1.33. What is the ratio of the Oil Rent (as % of GDP) in High income: OECD in 2008 to that in 2009?
Your answer should be compact. 1.8. What is the ratio of the Oil Rent (as % of GDP) in Other small states in 2008 to that in 2009?
Make the answer very short. 0.76. What is the ratio of the Oil Rent (as % of GDP) in Gabon in 2008 to that in 2009?
Ensure brevity in your answer.  1.34. What is the ratio of the Oil Rent (as % of GDP) in Vietnam in 2008 to that in 2009?
Provide a succinct answer. 1.67. What is the ratio of the Oil Rent (as % of GDP) of High income: OECD in 2008 to that in 2010?
Keep it short and to the point. 1.39. What is the ratio of the Oil Rent (as % of GDP) of Other small states in 2008 to that in 2010?
Make the answer very short. 0.69. What is the ratio of the Oil Rent (as % of GDP) in Gabon in 2008 to that in 2010?
Your answer should be very brief. 1.15. What is the ratio of the Oil Rent (as % of GDP) in Vietnam in 2008 to that in 2010?
Your answer should be compact. 1.44. What is the ratio of the Oil Rent (as % of GDP) in High income: OECD in 2008 to that in 2011?
Make the answer very short. 1.11. What is the ratio of the Oil Rent (as % of GDP) in Other small states in 2008 to that in 2011?
Your answer should be compact. 0.65. What is the ratio of the Oil Rent (as % of GDP) of Gabon in 2008 to that in 2011?
Offer a terse response. 1.07. What is the ratio of the Oil Rent (as % of GDP) of Vietnam in 2008 to that in 2011?
Provide a short and direct response. 1.3. What is the ratio of the Oil Rent (as % of GDP) in High income: OECD in 2008 to that in 2012?
Provide a short and direct response. 1.11. What is the ratio of the Oil Rent (as % of GDP) of Other small states in 2008 to that in 2012?
Your response must be concise. 0.66. What is the ratio of the Oil Rent (as % of GDP) in Gabon in 2008 to that in 2012?
Give a very brief answer. 1.11. What is the ratio of the Oil Rent (as % of GDP) of Vietnam in 2008 to that in 2012?
Ensure brevity in your answer.  1.35. What is the ratio of the Oil Rent (as % of GDP) of High income: OECD in 2009 to that in 2010?
Your response must be concise. 0.77. What is the ratio of the Oil Rent (as % of GDP) of Other small states in 2009 to that in 2010?
Offer a terse response. 0.92. What is the ratio of the Oil Rent (as % of GDP) in Gabon in 2009 to that in 2010?
Offer a terse response. 0.86. What is the ratio of the Oil Rent (as % of GDP) in Vietnam in 2009 to that in 2010?
Your answer should be compact. 0.86. What is the ratio of the Oil Rent (as % of GDP) in High income: OECD in 2009 to that in 2011?
Give a very brief answer. 0.62. What is the ratio of the Oil Rent (as % of GDP) in Other small states in 2009 to that in 2011?
Provide a short and direct response. 0.85. What is the ratio of the Oil Rent (as % of GDP) of Gabon in 2009 to that in 2011?
Offer a terse response. 0.79. What is the ratio of the Oil Rent (as % of GDP) in Vietnam in 2009 to that in 2011?
Give a very brief answer. 0.78. What is the ratio of the Oil Rent (as % of GDP) in High income: OECD in 2009 to that in 2012?
Ensure brevity in your answer.  0.62. What is the ratio of the Oil Rent (as % of GDP) in Other small states in 2009 to that in 2012?
Provide a succinct answer. 0.87. What is the ratio of the Oil Rent (as % of GDP) of Gabon in 2009 to that in 2012?
Your response must be concise. 0.83. What is the ratio of the Oil Rent (as % of GDP) in Vietnam in 2009 to that in 2012?
Give a very brief answer. 0.81. What is the ratio of the Oil Rent (as % of GDP) in High income: OECD in 2010 to that in 2011?
Offer a very short reply. 0.8. What is the ratio of the Oil Rent (as % of GDP) of Other small states in 2010 to that in 2011?
Provide a short and direct response. 0.93. What is the ratio of the Oil Rent (as % of GDP) in Gabon in 2010 to that in 2011?
Make the answer very short. 0.93. What is the ratio of the Oil Rent (as % of GDP) in Vietnam in 2010 to that in 2011?
Give a very brief answer. 0.9. What is the ratio of the Oil Rent (as % of GDP) in High income: OECD in 2010 to that in 2012?
Ensure brevity in your answer.  0.8. What is the ratio of the Oil Rent (as % of GDP) of Other small states in 2010 to that in 2012?
Offer a very short reply. 0.95. What is the ratio of the Oil Rent (as % of GDP) of Gabon in 2010 to that in 2012?
Offer a very short reply. 0.97. What is the ratio of the Oil Rent (as % of GDP) in Vietnam in 2010 to that in 2012?
Ensure brevity in your answer.  0.94. What is the ratio of the Oil Rent (as % of GDP) of High income: OECD in 2011 to that in 2012?
Give a very brief answer. 1. What is the ratio of the Oil Rent (as % of GDP) in Other small states in 2011 to that in 2012?
Your response must be concise. 1.02. What is the ratio of the Oil Rent (as % of GDP) in Gabon in 2011 to that in 2012?
Your response must be concise. 1.04. What is the ratio of the Oil Rent (as % of GDP) in Vietnam in 2011 to that in 2012?
Give a very brief answer. 1.04. What is the difference between the highest and the second highest Oil Rent (as % of GDP) in High income: OECD?
Your response must be concise. 0.08. What is the difference between the highest and the second highest Oil Rent (as % of GDP) of Other small states?
Offer a very short reply. 2.25. What is the difference between the highest and the second highest Oil Rent (as % of GDP) of Gabon?
Provide a short and direct response. 3.05. What is the difference between the highest and the second highest Oil Rent (as % of GDP) in Vietnam?
Keep it short and to the point. 0.1. What is the difference between the highest and the lowest Oil Rent (as % of GDP) of High income: OECD?
Your answer should be compact. 0.36. What is the difference between the highest and the lowest Oil Rent (as % of GDP) of Other small states?
Offer a terse response. 8.88. What is the difference between the highest and the lowest Oil Rent (as % of GDP) in Gabon?
Keep it short and to the point. 12.57. What is the difference between the highest and the lowest Oil Rent (as % of GDP) in Vietnam?
Provide a short and direct response. 3.89. 